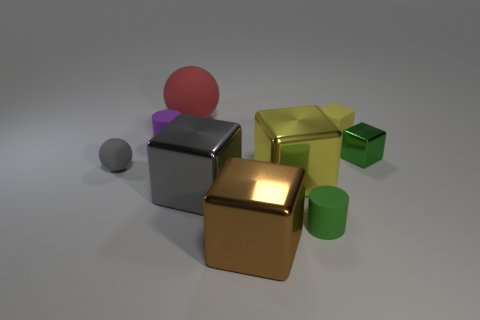Subtract all small green cubes. How many cubes are left? 4 Subtract all brown cubes. How many cubes are left? 4 Subtract all gray blocks. Subtract all blue spheres. How many blocks are left? 4 Subtract all balls. How many objects are left? 7 Add 7 green shiny objects. How many green shiny objects exist? 8 Subtract 0 yellow spheres. How many objects are left? 9 Subtract all purple objects. Subtract all small yellow things. How many objects are left? 7 Add 5 purple objects. How many purple objects are left? 6 